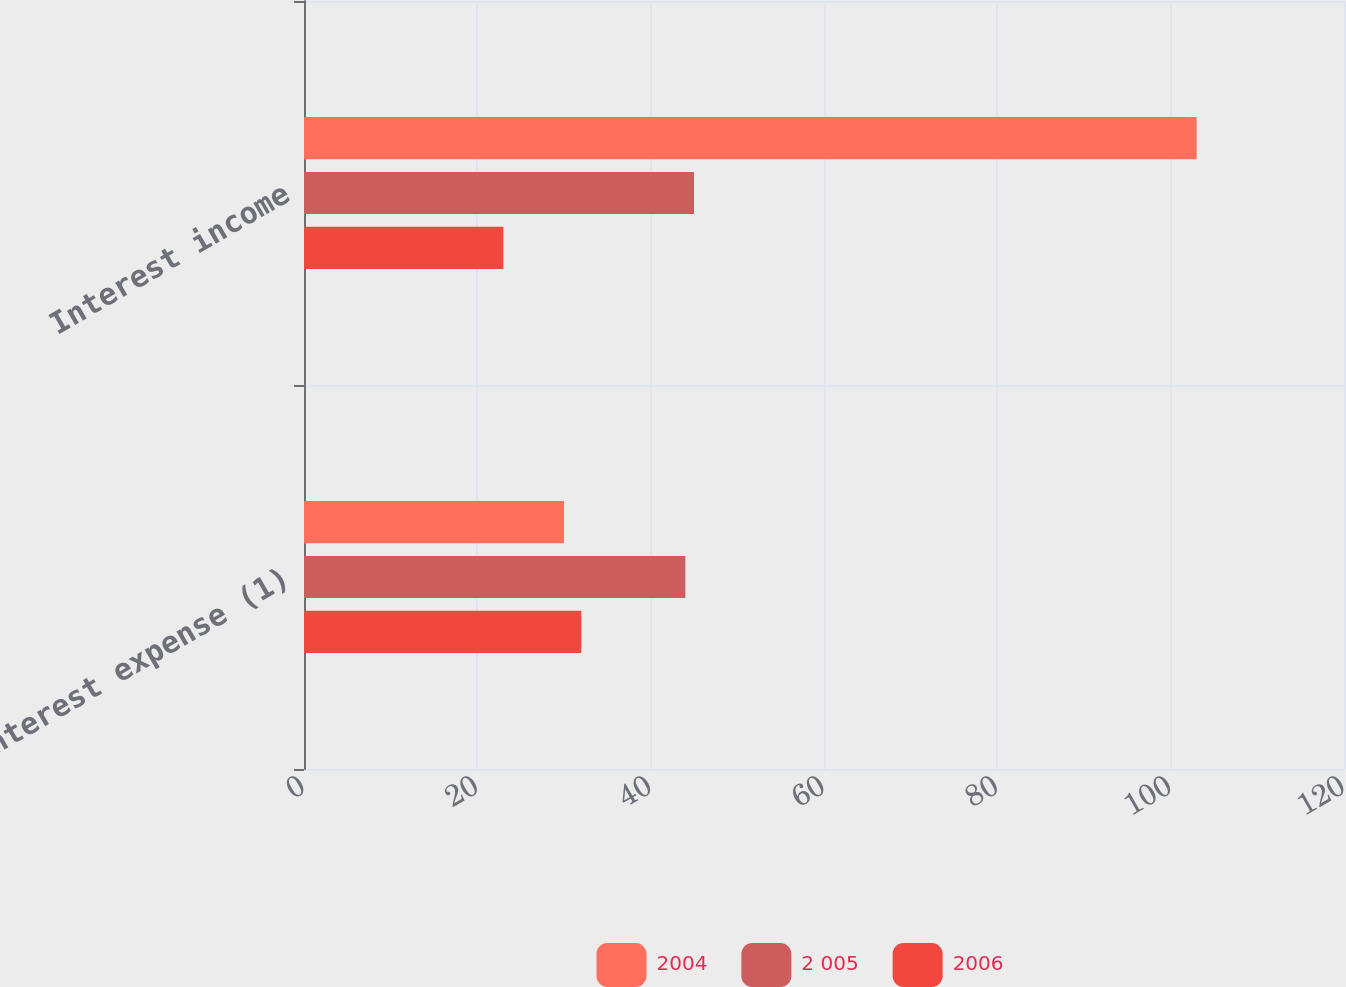Convert chart to OTSL. <chart><loc_0><loc_0><loc_500><loc_500><stacked_bar_chart><ecel><fcel>Interest expense (1)<fcel>Interest income<nl><fcel>2004<fcel>30<fcel>103<nl><fcel>2 005<fcel>44<fcel>45<nl><fcel>2006<fcel>32<fcel>23<nl></chart> 